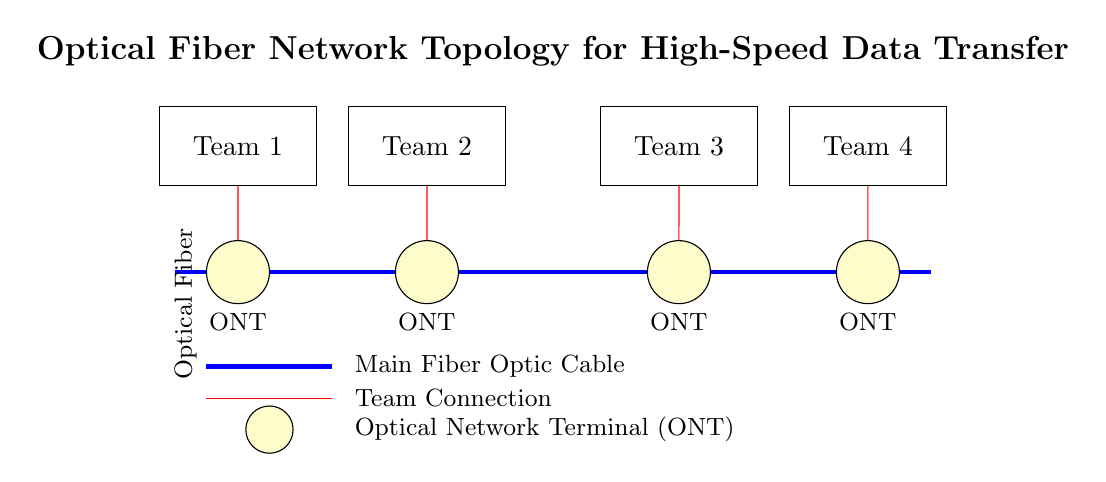What is the main component used for data transfer? The main component for data transfer is the optical fiber cable, which serves as the backbone for the network. It connects all the teams with high-speed communication capabilities.
Answer: optical fiber cable How many development teams are connected to the network? There are four development teams connected to the network, as represented by the four rectangles labeled Team 1 to Team 4 in the diagram.
Answer: four What connects each team to the optical fiber? Each team is connected to the optical fiber via an Optical Network Terminal (ONT), which are the yellow circles depicted in the circuit diagram under each team.
Answer: Optical Network Terminal What type of network topology is depicted in this diagram? The network topology depicted in the circuit diagram is a star topology, where all teams are connected individually to a central medium, the optical fiber.
Answer: star topology What is the color of the main optical fiber cable? The main optical fiber cable is represented in blue, indicating its significance and differentiation from the other network components in the diagram.
Answer: blue Which team is the closest to the optical fiber cable? Team 1 is the closest to the optical fiber cable, as it is located nearest to the starting point of the blue optical fiber line in the diagram.
Answer: Team 1 